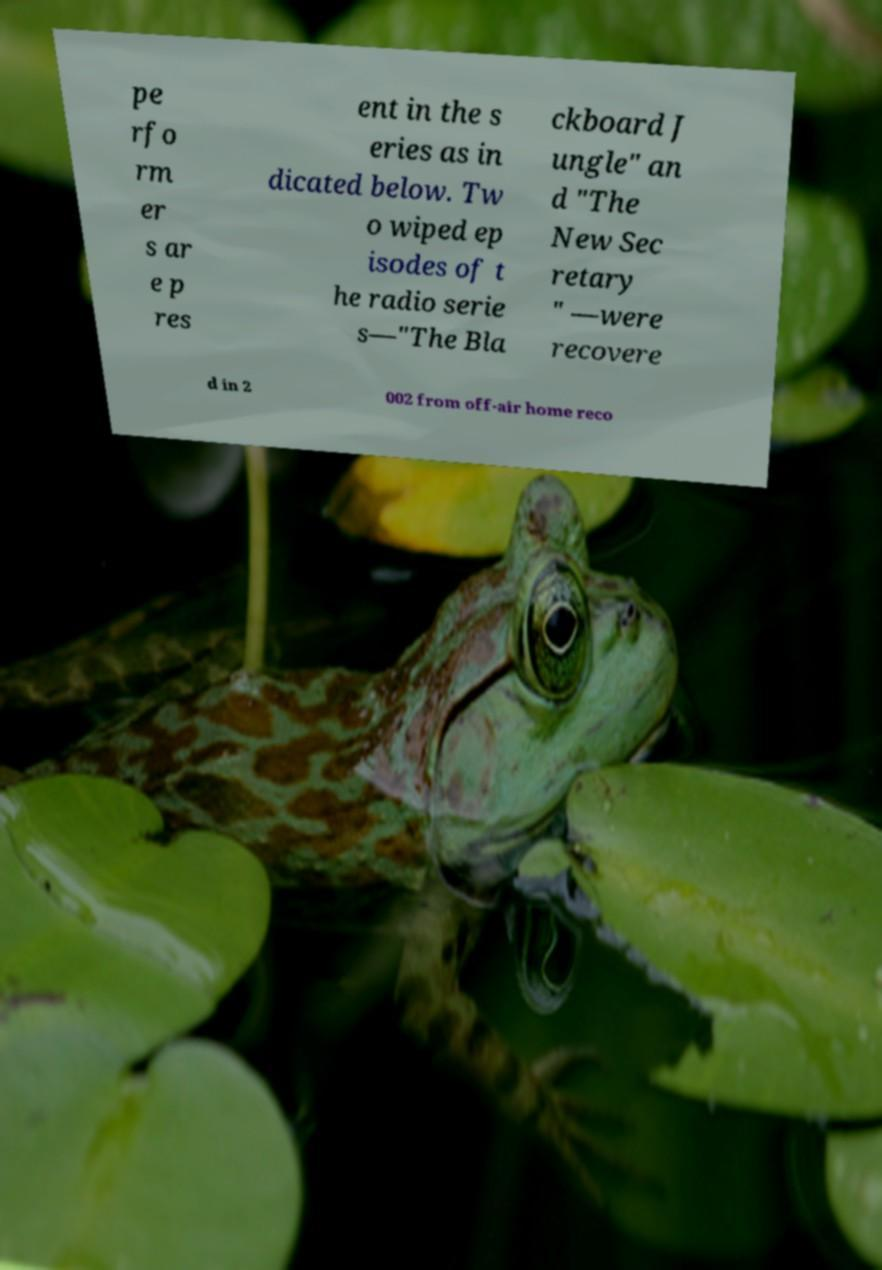Can you read and provide the text displayed in the image?This photo seems to have some interesting text. Can you extract and type it out for me? pe rfo rm er s ar e p res ent in the s eries as in dicated below. Tw o wiped ep isodes of t he radio serie s—"The Bla ckboard J ungle" an d "The New Sec retary " —were recovere d in 2 002 from off-air home reco 